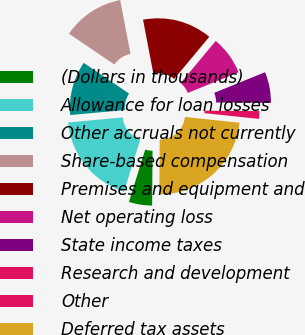<chart> <loc_0><loc_0><loc_500><loc_500><pie_chart><fcel>(Dollars in thousands)<fcel>Allowance for loan losses<fcel>Other accruals not currently<fcel>Share-based compensation<fcel>Premises and equipment and<fcel>Net operating loss<fcel>State income taxes<fcel>Research and development<fcel>Other<fcel>Deferred tax assets<nl><fcel>4.69%<fcel>18.75%<fcel>10.94%<fcel>12.5%<fcel>14.06%<fcel>7.81%<fcel>6.25%<fcel>1.56%<fcel>0.0%<fcel>23.44%<nl></chart> 